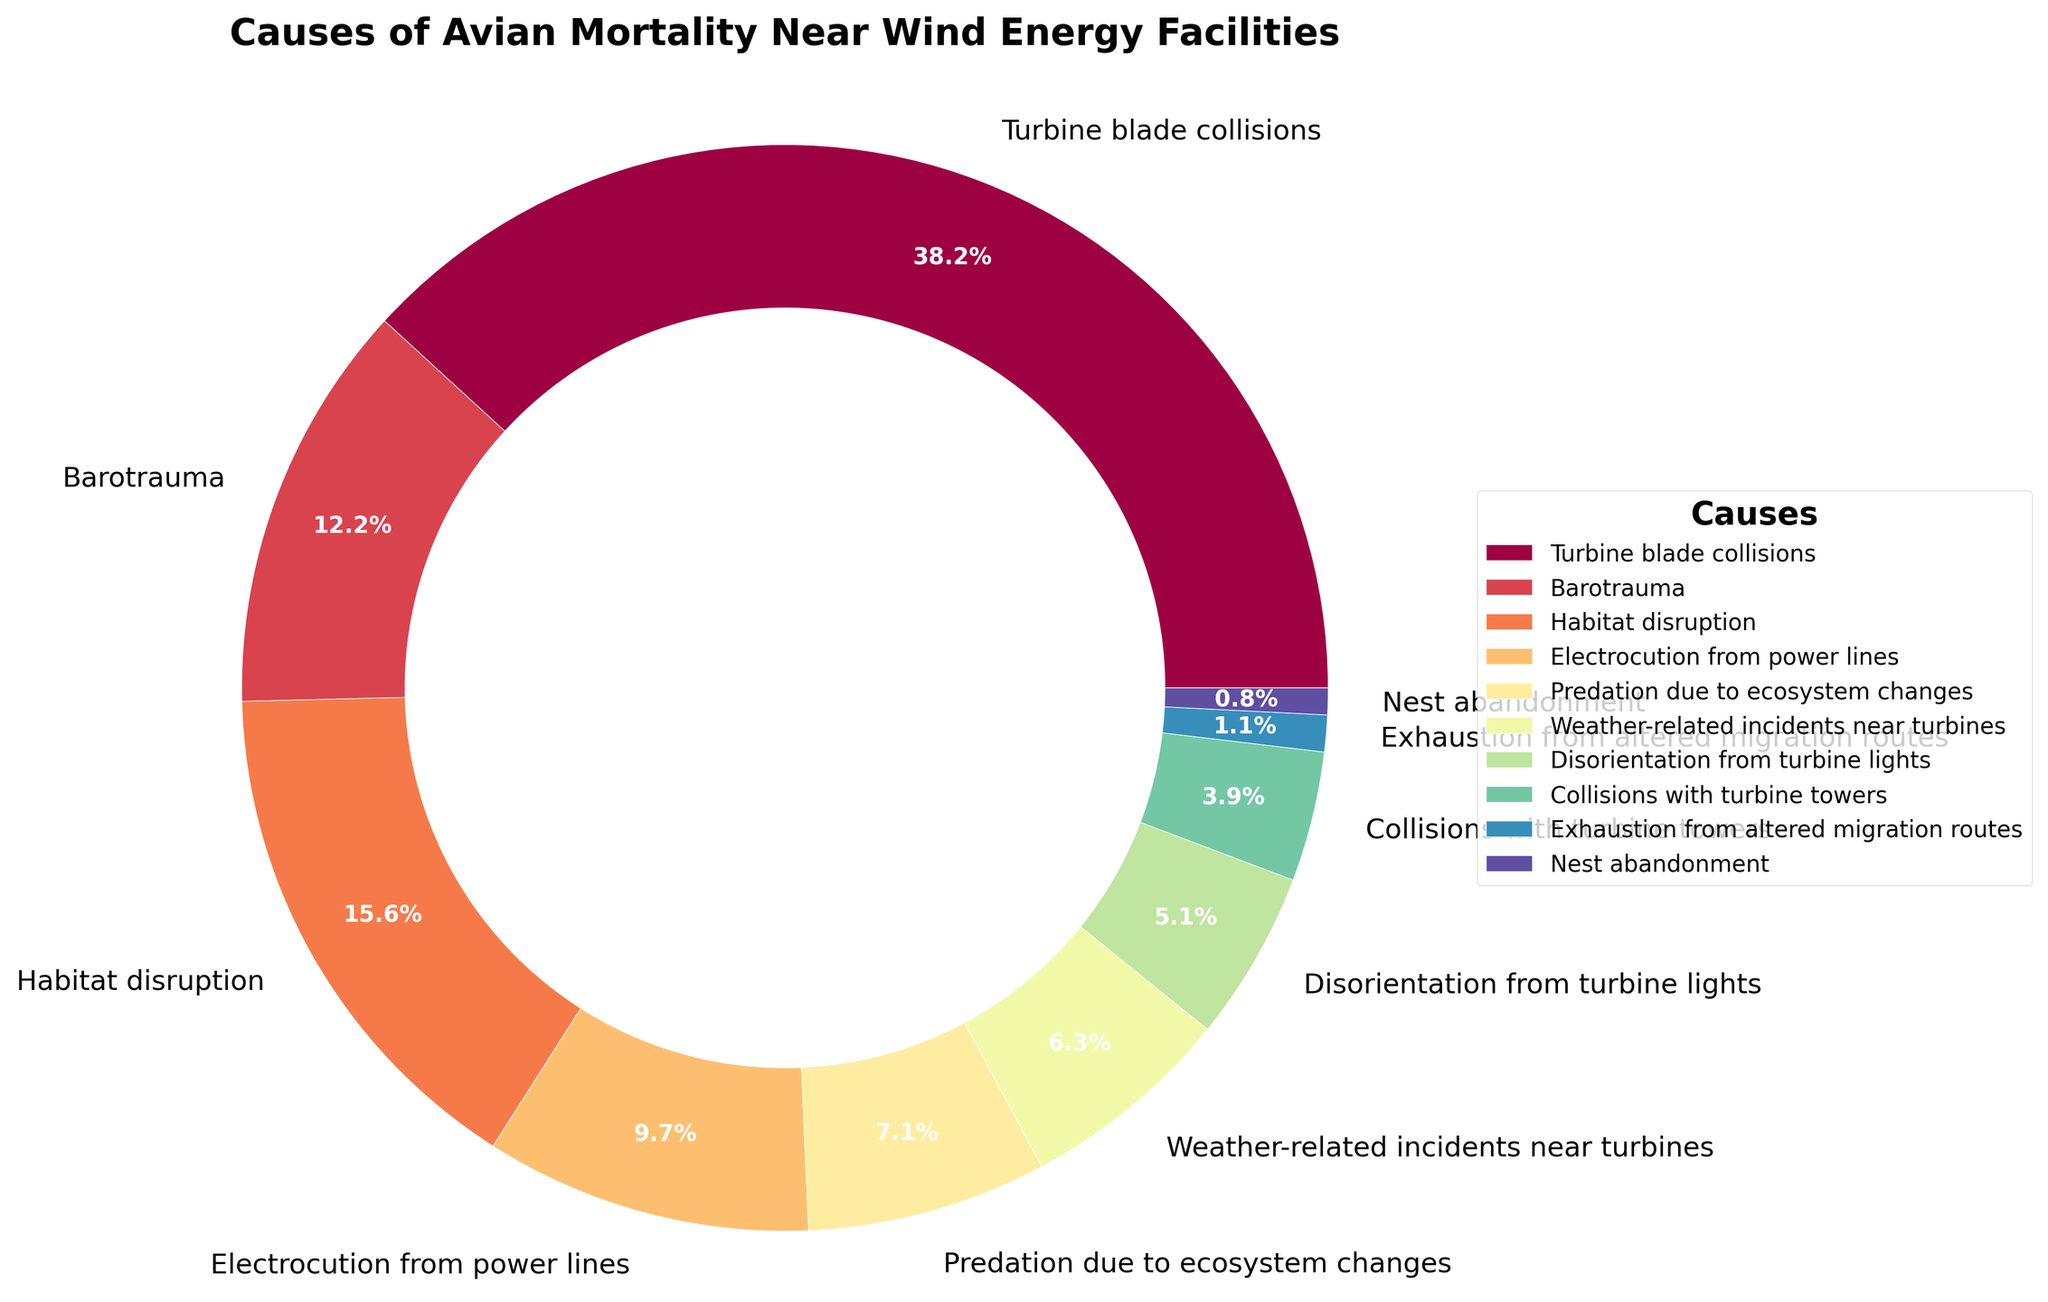Which cause of avian mortality near wind energy facilities is the most significant? The largest wedge in the pie chart represents the most significant cause. The slice corresponding to 'Turbine blade collisions' is the largest, indicating it is the most significant cause of avian mortality.
Answer: Turbine blade collisions What percentage of avian mortality is caused by Collisions with turbine towers and Exhaustion from altered migration routes combined? To find this, sum the percentages for 'Collisions with turbine towers' and 'Exhaustion from altered migration routes'. These are 3.9% and 1.1%, respectively. So, 3.9% + 1.1% = 5%.
Answer: 5% How does Electrocution from power lines compare to Predation due to ecosystem changes in terms of percentage of avian mortality? Compare the percentages directly from the pie chart. 'Electrocution from power lines' accounts for 9.8%, while 'Predation due to ecosystem changes' accounts for 7.2%. Thus, Electrocution from power lines has a higher percentage.
Answer: Electrocution from power lines has a higher percentage What is the visual color gradient used for depicting the causes? Identify the colors used in the pie chart, noting the gradient effect. The causes are represented using a gradient that transitions through a spectrum of colors – often from warm colors like red and orange to cooler colors like blue and purple.
Answer: Gradient from red to blue/purple How much more significant is Habitat disruption compared to Disorientation from turbine lights in causing avian mortality? Subtract the percentage of 'Disorientation from turbine lights' from 'Habitat disruption' to determine the difference. 'Habitat disruption' is 15.7% and 'Disorientation from turbine lights' is 5.1%, so 15.7% - 5.1% = 10.6%.
Answer: 10.6% What portion of avian mortality is not related to any collisions (sum of non-collision related causes)? To find this, sum the percentages of all causes except 'Turbine blade collisions' and 'Collisions with turbine towers'. Other causes are: Barotrauma (12.3%) + Habitat disruption (15.7%) + Electrocution from power lines (9.8%) + Predation due to ecosystem changes (7.2%) + Weather-related incidents near turbines (6.4%) + Disorientation from turbine lights (5.1%) + Exhaustion from altered migration routes (1.1%) + Nest abandonment (0.8%), which totals 58.4%.
Answer: 58.4% What percentage of avian mortality is caused by factors other than Turbine blade collisions and Habitat disruption? Subtract the combined percentages of 'Turbine blade collisions' and 'Habitat disruption' from 100%. 'Turbine blade collisions' is 38.5% and 'Habitat disruption' is 15.7%, so their total is 38.5% + 15.7% = 54.2%. Then 100% - 54.2% = 45.8%.
Answer: 45.8% Where does Barotrauma rank in terms of common causes of avian mortality? List the causes in descending order of their percentages and find the position of 'Barotrauma'. The ranking would be 'Turbine blade collisions' (38.5%), 'Habitat disruption' (15.7%), and then 'Barotrauma' (12.3%). 'Barotrauma' is the third most common cause.
Answer: Third 